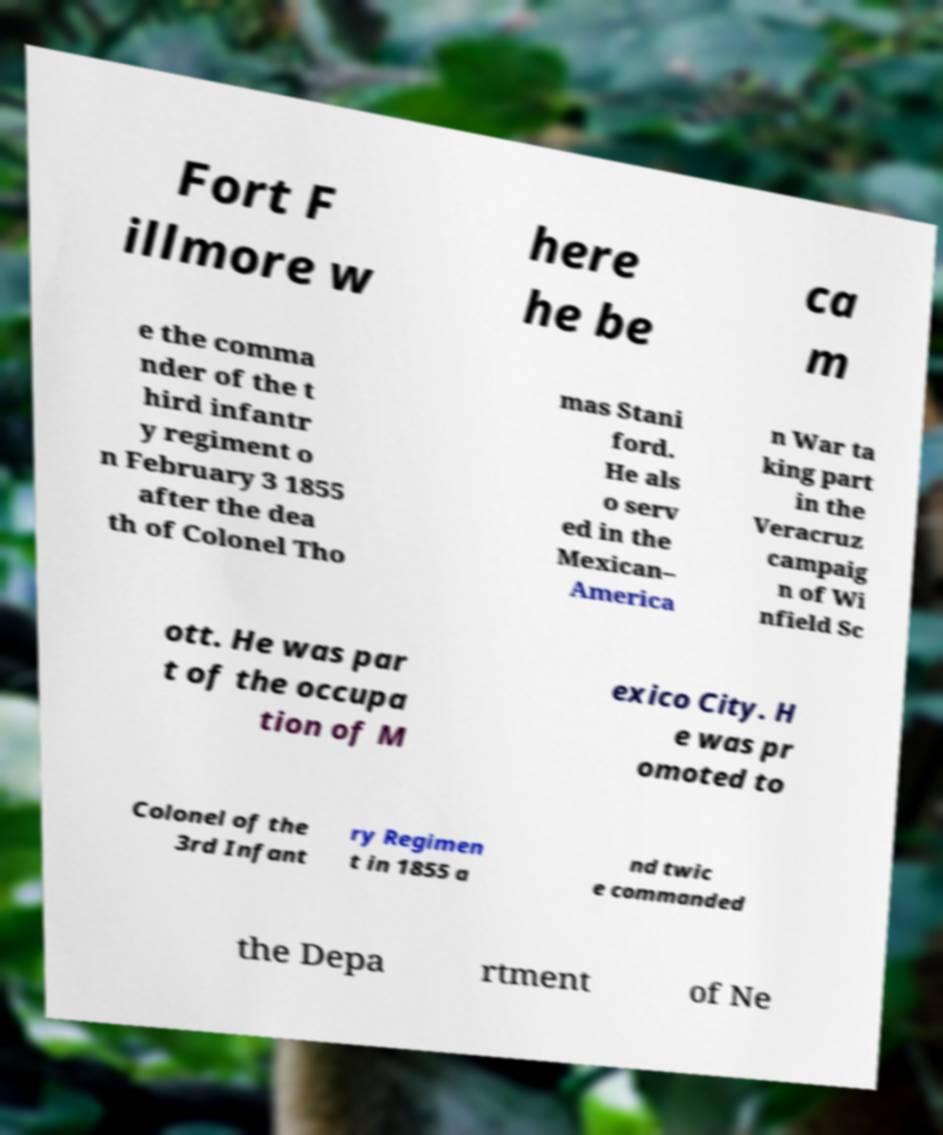For documentation purposes, I need the text within this image transcribed. Could you provide that? Fort F illmore w here he be ca m e the comma nder of the t hird infantr y regiment o n February 3 1855 after the dea th of Colonel Tho mas Stani ford. He als o serv ed in the Mexican– America n War ta king part in the Veracruz campaig n of Wi nfield Sc ott. He was par t of the occupa tion of M exico City. H e was pr omoted to Colonel of the 3rd Infant ry Regimen t in 1855 a nd twic e commanded the Depa rtment of Ne 